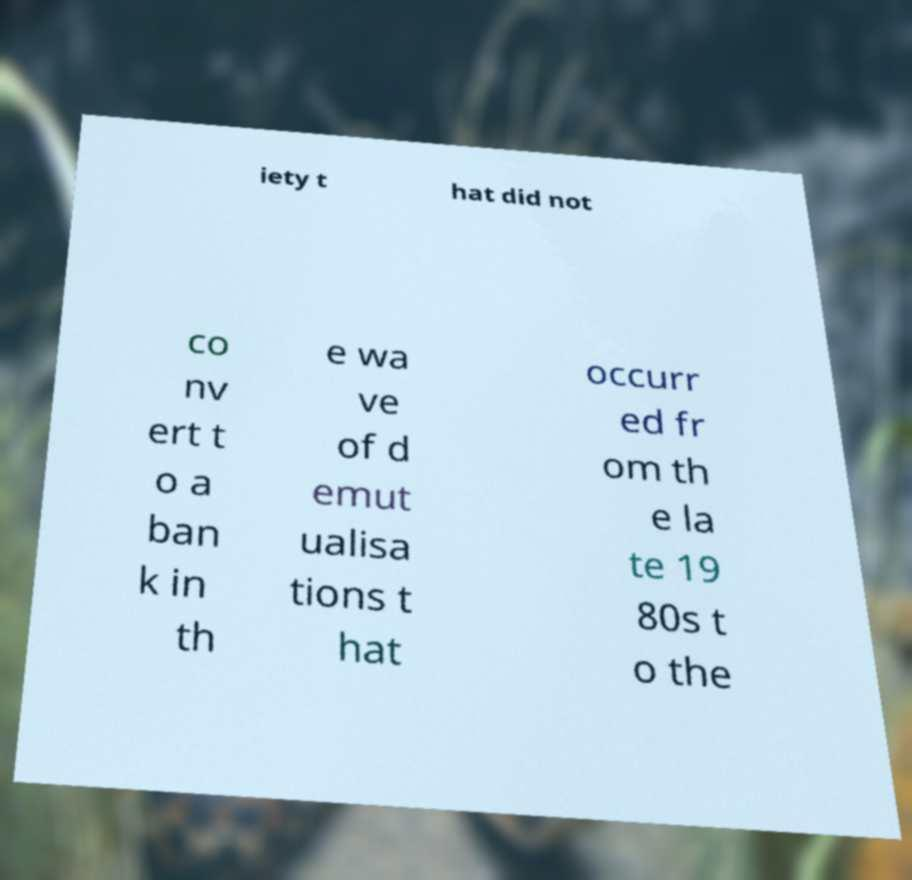I need the written content from this picture converted into text. Can you do that? iety t hat did not co nv ert t o a ban k in th e wa ve of d emut ualisa tions t hat occurr ed fr om th e la te 19 80s t o the 